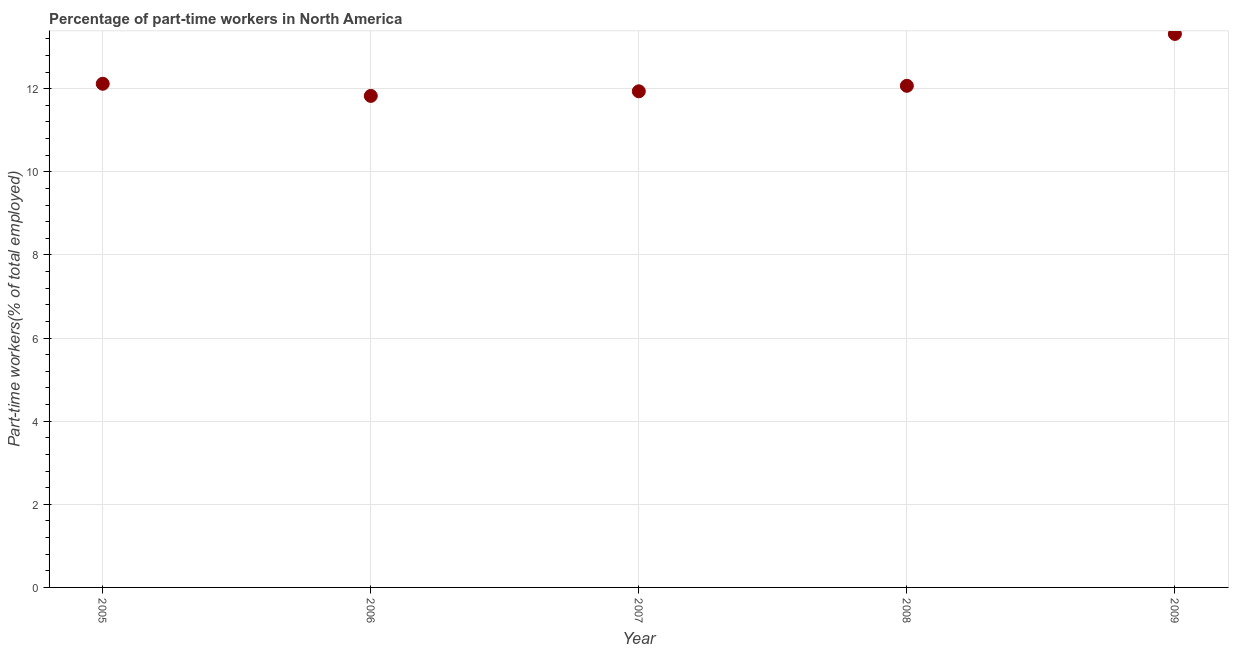What is the percentage of part-time workers in 2007?
Your answer should be compact. 11.94. Across all years, what is the maximum percentage of part-time workers?
Give a very brief answer. 13.32. Across all years, what is the minimum percentage of part-time workers?
Offer a very short reply. 11.83. In which year was the percentage of part-time workers maximum?
Your response must be concise. 2009. In which year was the percentage of part-time workers minimum?
Ensure brevity in your answer.  2006. What is the sum of the percentage of part-time workers?
Ensure brevity in your answer.  61.26. What is the difference between the percentage of part-time workers in 2005 and 2006?
Give a very brief answer. 0.29. What is the average percentage of part-time workers per year?
Your answer should be very brief. 12.25. What is the median percentage of part-time workers?
Your answer should be compact. 12.07. Do a majority of the years between 2005 and 2007 (inclusive) have percentage of part-time workers greater than 4.8 %?
Your answer should be compact. Yes. What is the ratio of the percentage of part-time workers in 2006 to that in 2008?
Keep it short and to the point. 0.98. What is the difference between the highest and the second highest percentage of part-time workers?
Your answer should be compact. 1.2. What is the difference between the highest and the lowest percentage of part-time workers?
Keep it short and to the point. 1.49. How many dotlines are there?
Offer a very short reply. 1. Are the values on the major ticks of Y-axis written in scientific E-notation?
Ensure brevity in your answer.  No. Does the graph contain grids?
Make the answer very short. Yes. What is the title of the graph?
Make the answer very short. Percentage of part-time workers in North America. What is the label or title of the X-axis?
Give a very brief answer. Year. What is the label or title of the Y-axis?
Provide a short and direct response. Part-time workers(% of total employed). What is the Part-time workers(% of total employed) in 2005?
Offer a terse response. 12.12. What is the Part-time workers(% of total employed) in 2006?
Your response must be concise. 11.83. What is the Part-time workers(% of total employed) in 2007?
Give a very brief answer. 11.94. What is the Part-time workers(% of total employed) in 2008?
Provide a succinct answer. 12.07. What is the Part-time workers(% of total employed) in 2009?
Provide a short and direct response. 13.32. What is the difference between the Part-time workers(% of total employed) in 2005 and 2006?
Provide a succinct answer. 0.29. What is the difference between the Part-time workers(% of total employed) in 2005 and 2007?
Your answer should be very brief. 0.18. What is the difference between the Part-time workers(% of total employed) in 2005 and 2008?
Offer a very short reply. 0.05. What is the difference between the Part-time workers(% of total employed) in 2005 and 2009?
Your answer should be very brief. -1.2. What is the difference between the Part-time workers(% of total employed) in 2006 and 2007?
Offer a terse response. -0.11. What is the difference between the Part-time workers(% of total employed) in 2006 and 2008?
Your response must be concise. -0.24. What is the difference between the Part-time workers(% of total employed) in 2006 and 2009?
Offer a very short reply. -1.49. What is the difference between the Part-time workers(% of total employed) in 2007 and 2008?
Your answer should be compact. -0.13. What is the difference between the Part-time workers(% of total employed) in 2007 and 2009?
Offer a terse response. -1.38. What is the difference between the Part-time workers(% of total employed) in 2008 and 2009?
Ensure brevity in your answer.  -1.25. What is the ratio of the Part-time workers(% of total employed) in 2005 to that in 2007?
Offer a terse response. 1.01. What is the ratio of the Part-time workers(% of total employed) in 2005 to that in 2008?
Your answer should be very brief. 1. What is the ratio of the Part-time workers(% of total employed) in 2005 to that in 2009?
Offer a terse response. 0.91. What is the ratio of the Part-time workers(% of total employed) in 2006 to that in 2007?
Your response must be concise. 0.99. What is the ratio of the Part-time workers(% of total employed) in 2006 to that in 2009?
Provide a short and direct response. 0.89. What is the ratio of the Part-time workers(% of total employed) in 2007 to that in 2009?
Your response must be concise. 0.9. What is the ratio of the Part-time workers(% of total employed) in 2008 to that in 2009?
Your answer should be compact. 0.91. 